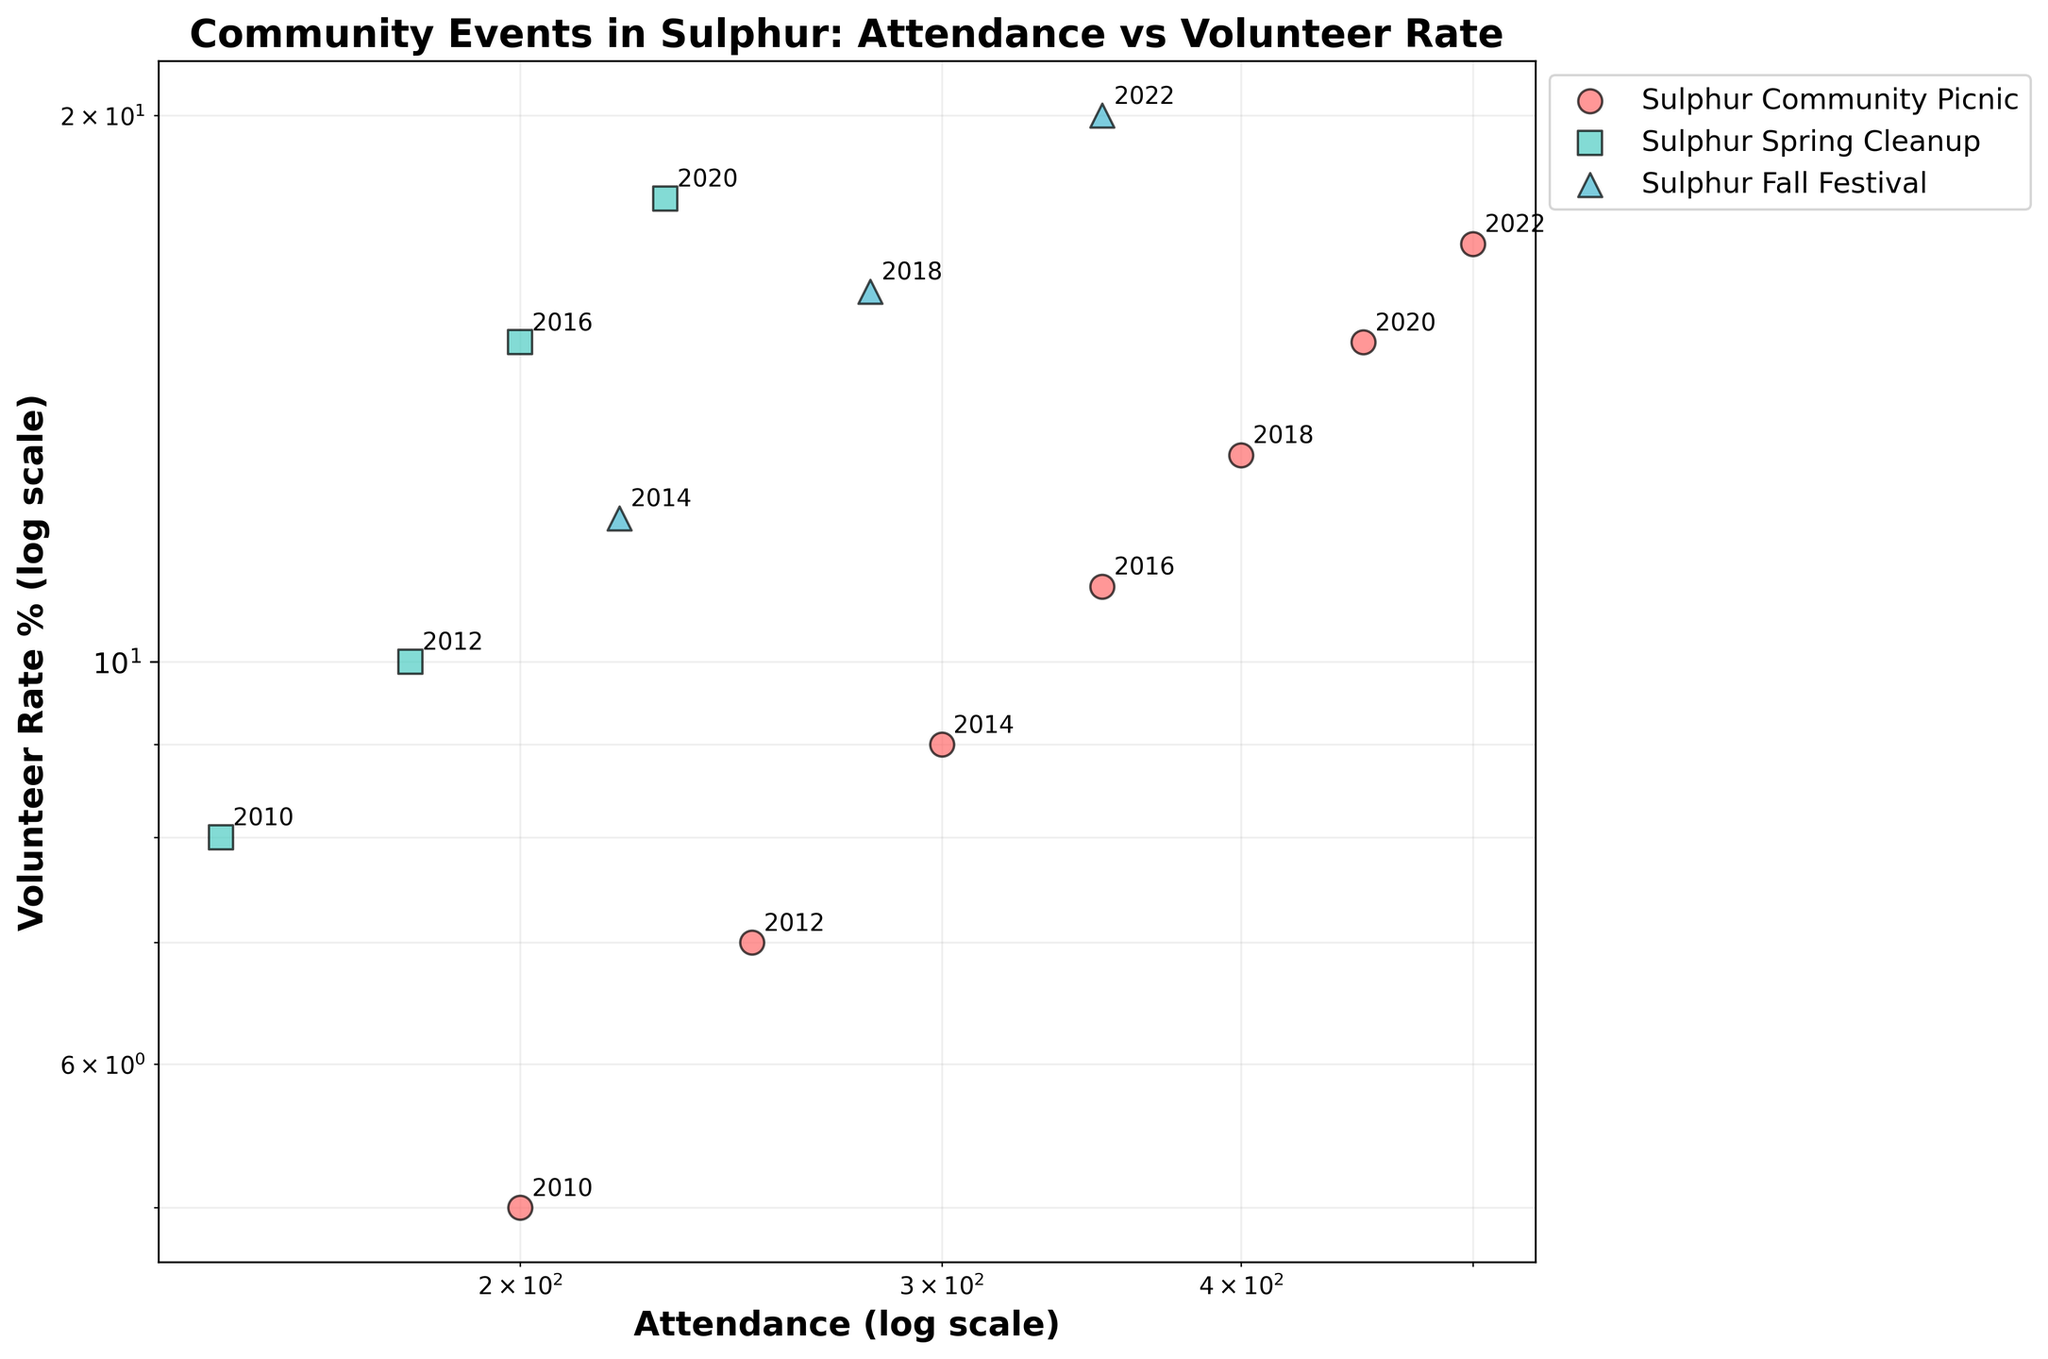How many different community events are represented in the plot? To determine the number of different community events, look at the legend on the plot which lists each unique event.
Answer: 3 Which community event had the highest volunteer rate in 2022? To answer this, find the points annotated with the year 2022 and compare their positions on the y-axis which represents the volunteer rate.
Answer: Sulphur Fall Festival How has the attendance of the Sulphur Community Picnic changed from 2010 to 2022? To figure this out, locate the data points for Sulphur Community Picnic in 2010 and 2022, then compare their positions on the x-axis which represents attendance.
Answer: Increased from 200 to 500 What is the general trend between attendance and volunteer rate in the plotted community events? Observing the direction in which the points are distributed on the log-log scale will help determine the relationship between attendance and volunteer rate.
Answer: As attendance increases, volunteer rate also increases How does the attendance of Sulphur Fall Festival in 2018 compare to Sulphur Spring Cleanup in 2020? Locate the points for Sulphur Fall Festival in 2018 and Sulphur Spring Cleanup in 2020, then compare their positions on the x-axis to see which has higher attendance.
Answer: Sulphur Fall Festival in 2018 has higher attendance What's the average volunteer rate for Sulphur Spring Cleanup events across all years? To calculate, sum the volunteer rates of all Sulphur Spring Cleanup events and then divide by the number of such events. Rates: 8, 10, 15, 18. Sum: 8 + 10 + 15 + 18 = 51. Number of events: 4. Average: 51 / 4 = 12.75
Answer: 12.75 Between 2012 and 2014, which event showed a greater increase in attendance: Sulphur Community Picnic or Sulphur Spring Cleanup? Calculate the change in attendance for each event between these years by subtracting 2012 attendance from 2014 attendance, then compare the increases. Picnic: 300 - 250 = 50. Cleanup: 0 (no data in 2014 for Cleanup)
Answer: Sulphur Community Picnic 